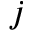<formula> <loc_0><loc_0><loc_500><loc_500>j</formula> 